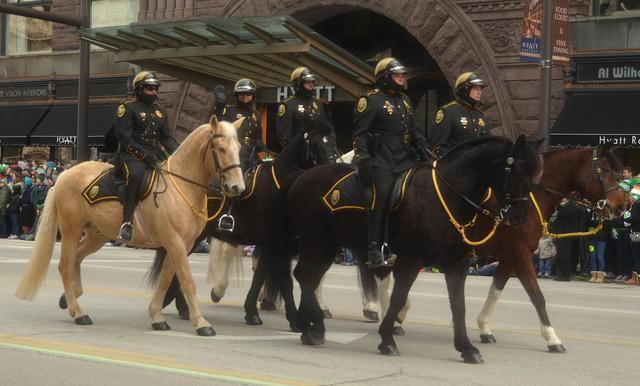How many horses do you see?
Give a very brief answer. 4. How many horses are in the picture?
Give a very brief answer. 4. How many riders are in the picture?
Give a very brief answer. 5. How many horses are there?
Give a very brief answer. 4. How many people can be seen?
Give a very brief answer. 6. 